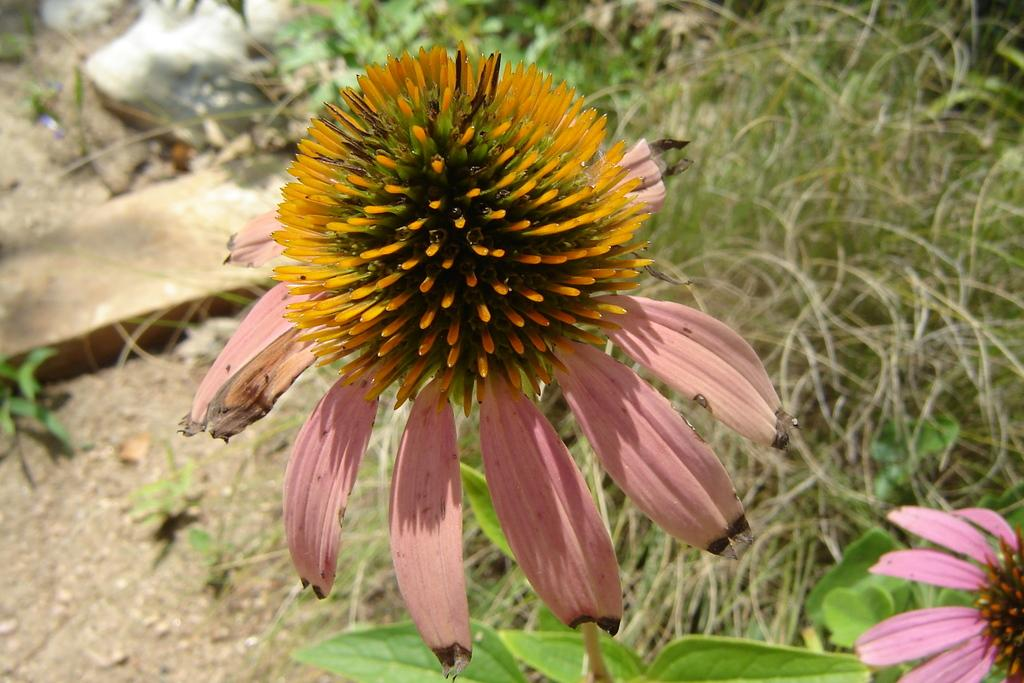What type of plant life is visible in the image? There is a flower and a plant visible in the image. What is the condition of the grass in the image? The grass in the image is dry. Can you see a tiger resting in the shade under the plant in the image? There is no tiger present in the image. What type of patch is covering the flower in the image? There is no patch covering the flower in the image; the flower is visible. 